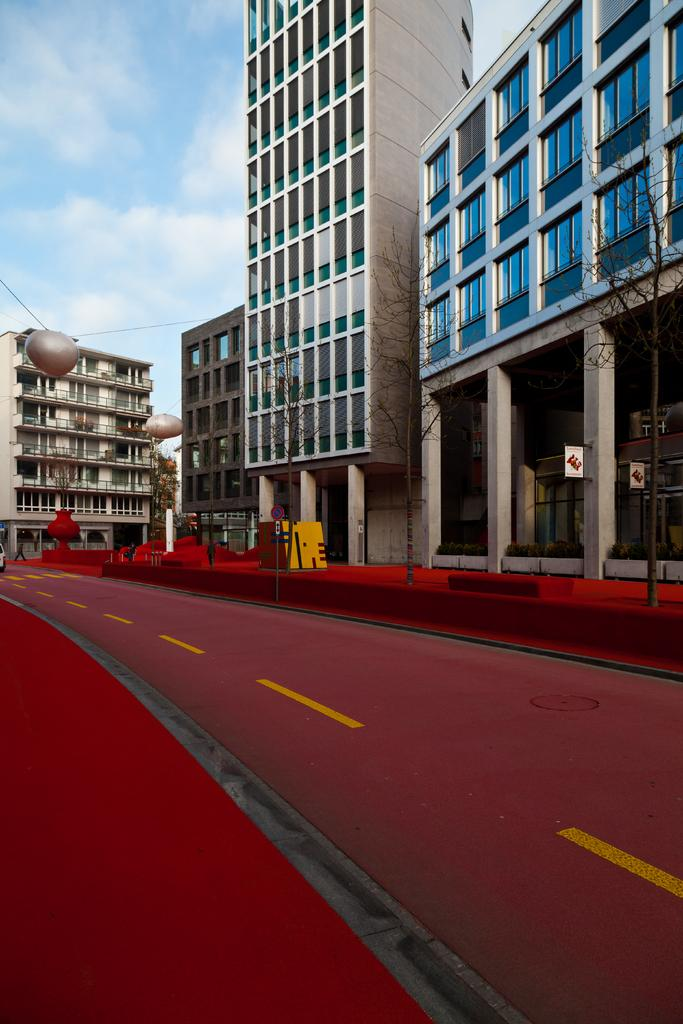What is the main feature in the middle of the picture? There is a road in the middle of the picture. What is the color of the road? The road is red in color. What can be seen in the background of the image? There are buildings and clouds in the sky in the background of the image. Where is the glove located in the image? There is no glove present in the image. What type of knee can be seen in the image? There is no knee visible in the image. 